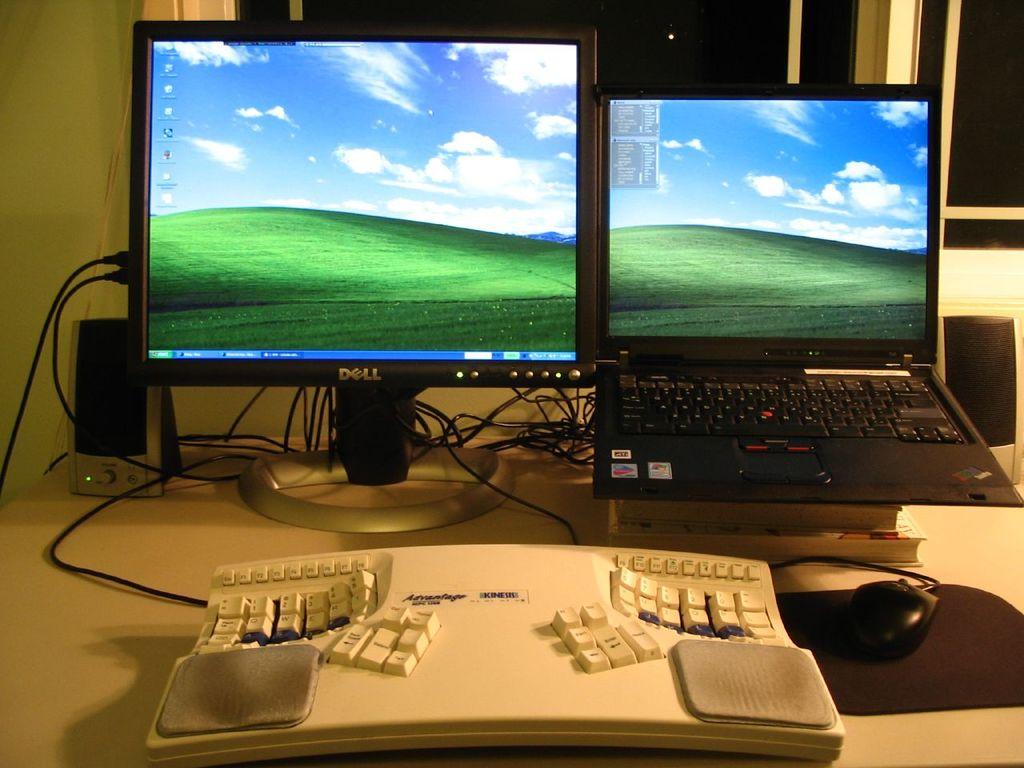What is teh brand of the monitor on the left?
Your answer should be compact. Dell. What is the word written in the keyboard?
Offer a very short reply. Unanswerable. 